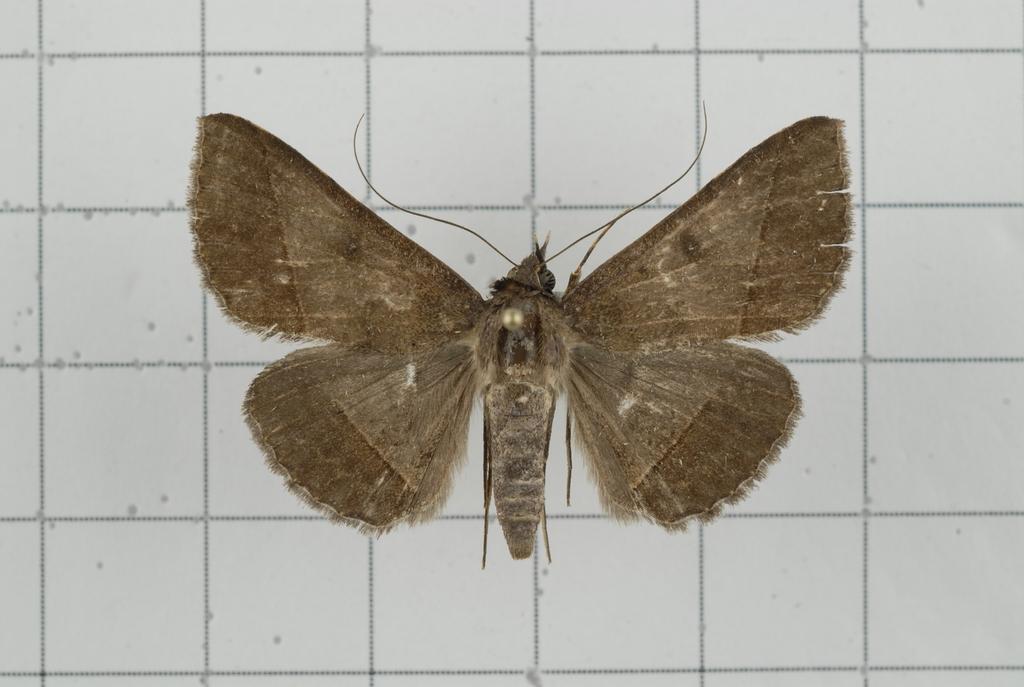Can you describe this image briefly? In this picture we can see a butterfly, in the background there are some tiles. 